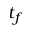<formula> <loc_0><loc_0><loc_500><loc_500>t _ { f }</formula> 